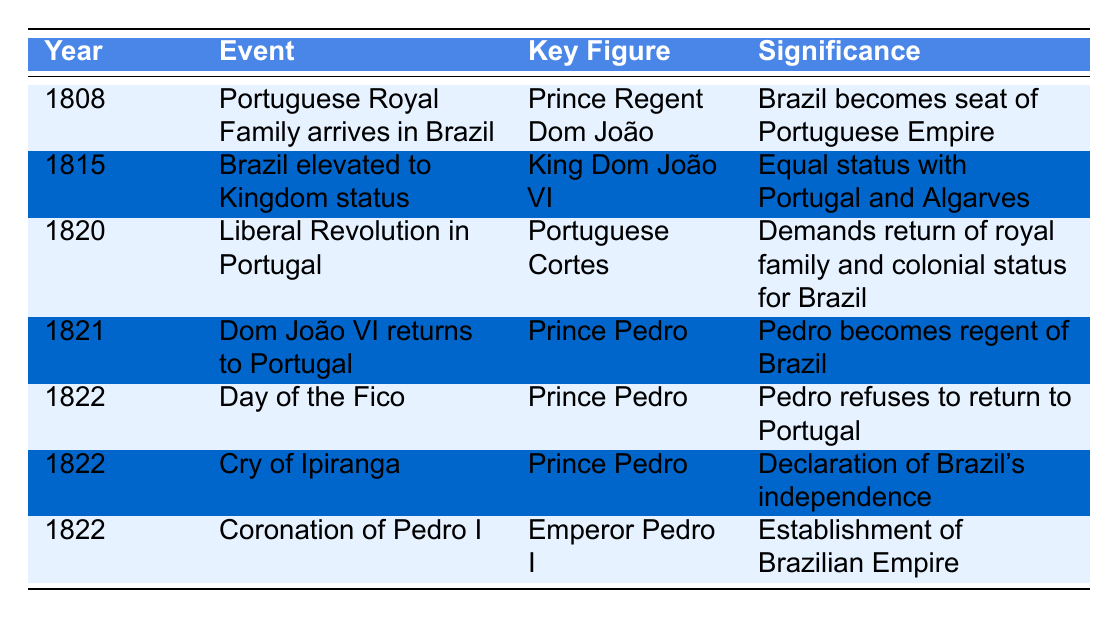What year did the Portuguese Royal Family arrive in Brazil? The table shows that the event "Portuguese Royal Family arrives in Brazil" occurred in the year 1808.
Answer: 1808 Who is the key figure associated with Brazil's elevation to Kingdom status? The table indicates that the event "Brazil elevated to Kingdom status" has King Dom João VI as the key figure.
Answer: King Dom João VI What significant event happened in 1822 that marked Brazil's independence? The table lists "Cry of Ipiranga" in 1822 as a declaration of Brazil's independence.
Answer: Cry of Ipiranga Did the Liberal Revolution in Portugal demand a return of the royal family? According to the table, the "Liberal Revolution in Portugal" event in 1820 did demand the return of the royal family and colonial status for Brazil.
Answer: Yes How many major events in the table occurred in the year 1822? The table describes three events that took place in 1822: "Day of the Fico," "Cry of Ipiranga," and "Coronation of Pedro I." Therefore, the total count is three.
Answer: 3 What was the significance of the Day of the Fico? The table states that during the "Day of the Fico," Prince Pedro refused to return to Portugal, which was a significant act during the independence movement.
Answer: Pedro refused to return to Portugal Which event occurred first: Brazil being elevated to Kingdom status or the Liberal Revolution in Portugal? By comparing the years in the table, Brazil was elevated to Kingdom status in 1815 and the Liberal Revolution occurred in 1820, making 1815 the earlier year.
Answer: Brazil elevated to Kingdom status What was the significance of Pedro I's coronation? The table indicates that the coronation of Pedro I marked the establishment of the Brazilian Empire.
Answer: Establishment of Brazilian Empire Who was the key figure during the event of 1821 when Dom João VI returned to Portugal? The event of 1821 in the table lists Prince Pedro as the key figure when Dom João VI returned to Portugal.
Answer: Prince Pedro How did events from 1808 to 1822 shape Brazil's political status? The table indicates a progression from Brazil becoming the seat of the Portuguese Empire in 1808 to its declaration of independence in 1822, demonstrating a shift towards political autonomy.
Answer: Shift towards political autonomy 